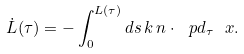<formula> <loc_0><loc_0><loc_500><loc_500>\dot { L } ( \tau ) = - \int _ { 0 } ^ { L ( \tau ) } d s \, k \, n \cdot \ p d _ { \tau } \ x .</formula> 